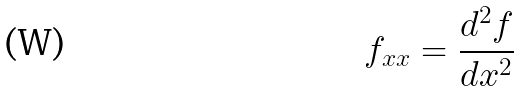Convert formula to latex. <formula><loc_0><loc_0><loc_500><loc_500>f _ { x x } = \frac { d ^ { 2 } f } { d x ^ { 2 } }</formula> 